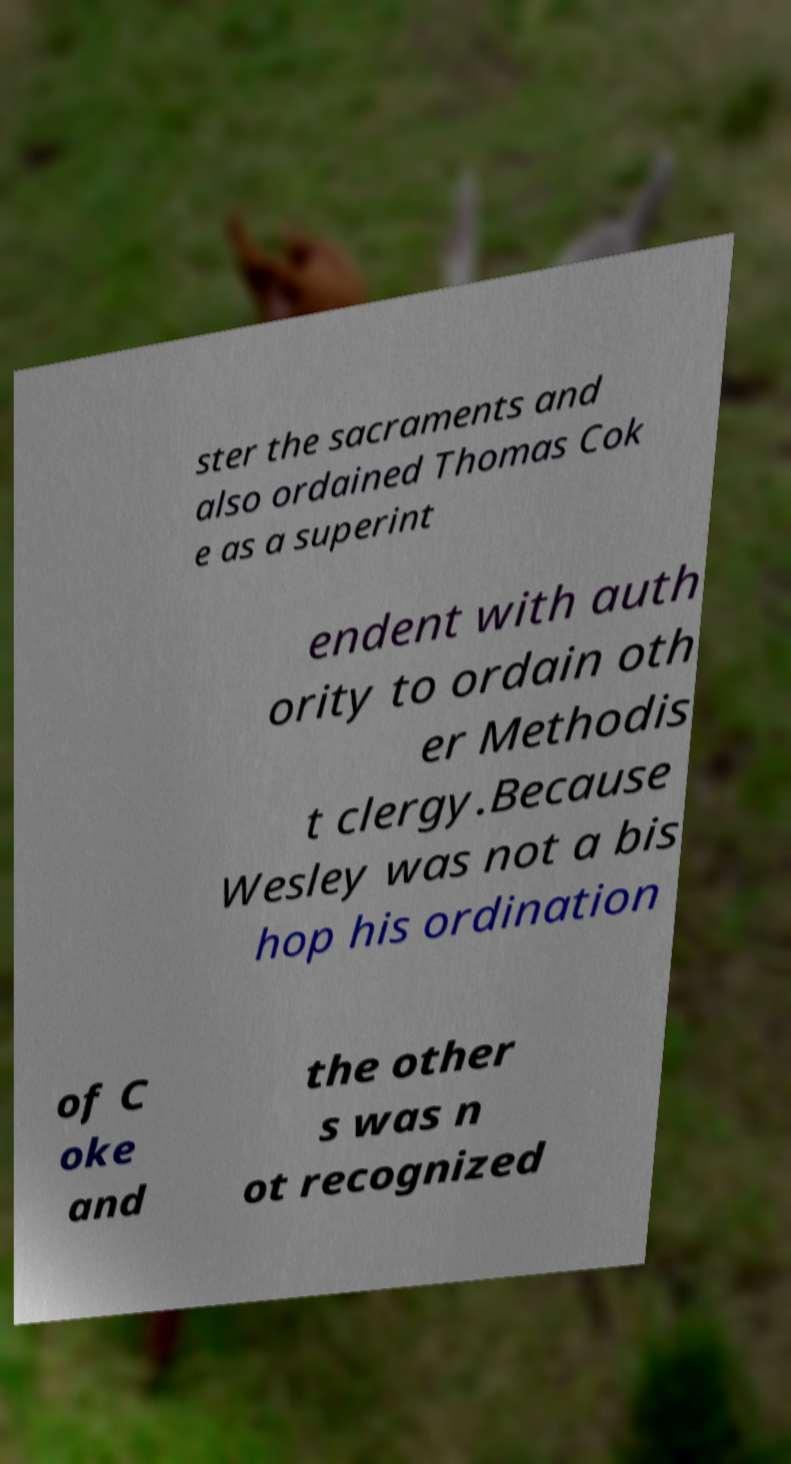Can you accurately transcribe the text from the provided image for me? ster the sacraments and also ordained Thomas Cok e as a superint endent with auth ority to ordain oth er Methodis t clergy.Because Wesley was not a bis hop his ordination of C oke and the other s was n ot recognized 